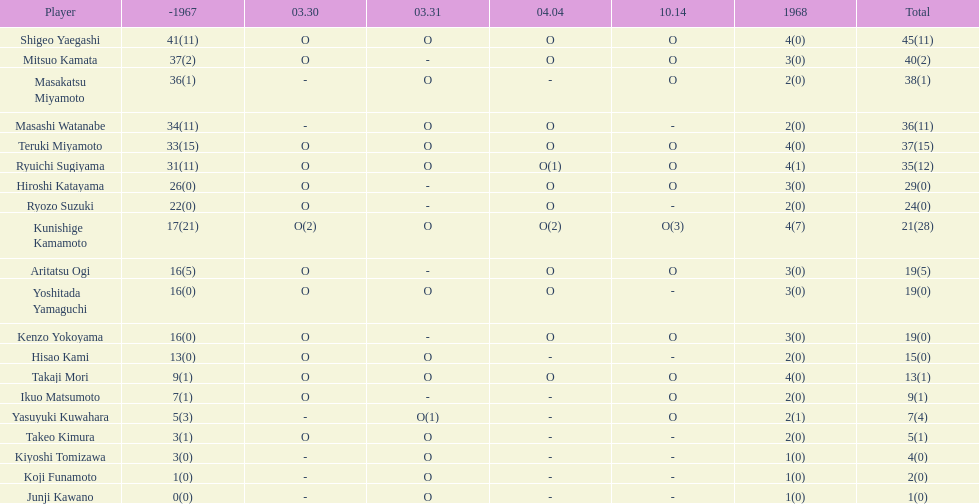Who had more points takaji mori or junji kawano? Takaji Mori. 